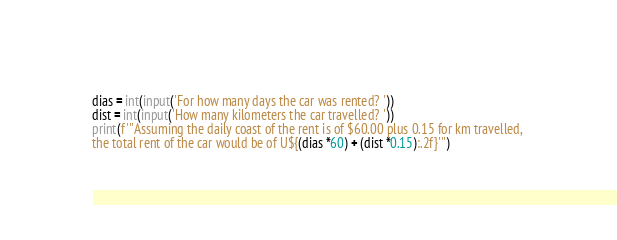Convert code to text. <code><loc_0><loc_0><loc_500><loc_500><_Python_>dias = int(input('For how many days the car was rented? '))
dist = int(input('How many kilometers the car travelled? '))
print(f'''Assuming the daily coast of the rent is of $60.00 plus 0.15 for km travelled, 
the total rent of the car would be of U${(dias *60) + (dist *0.15):.2f}''')
</code> 